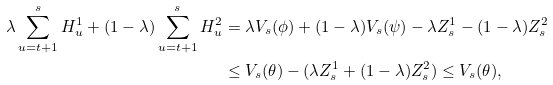<formula> <loc_0><loc_0><loc_500><loc_500>\lambda \sum ^ { s } _ { u = t + 1 } H ^ { 1 } _ { u } + ( 1 - \lambda ) \sum ^ { s } _ { u = t + 1 } H ^ { 2 } _ { u } & = \lambda V _ { s } ( \phi ) + ( 1 - \lambda ) V _ { s } ( \psi ) - \lambda Z ^ { 1 } _ { s } - ( 1 - \lambda ) Z ^ { 2 } _ { s } \\ & \leq V _ { s } ( \theta ) - ( \lambda Z ^ { 1 } _ { s } + ( 1 - \lambda ) Z ^ { 2 } _ { s } ) \leq V _ { s } ( \theta ) ,</formula> 